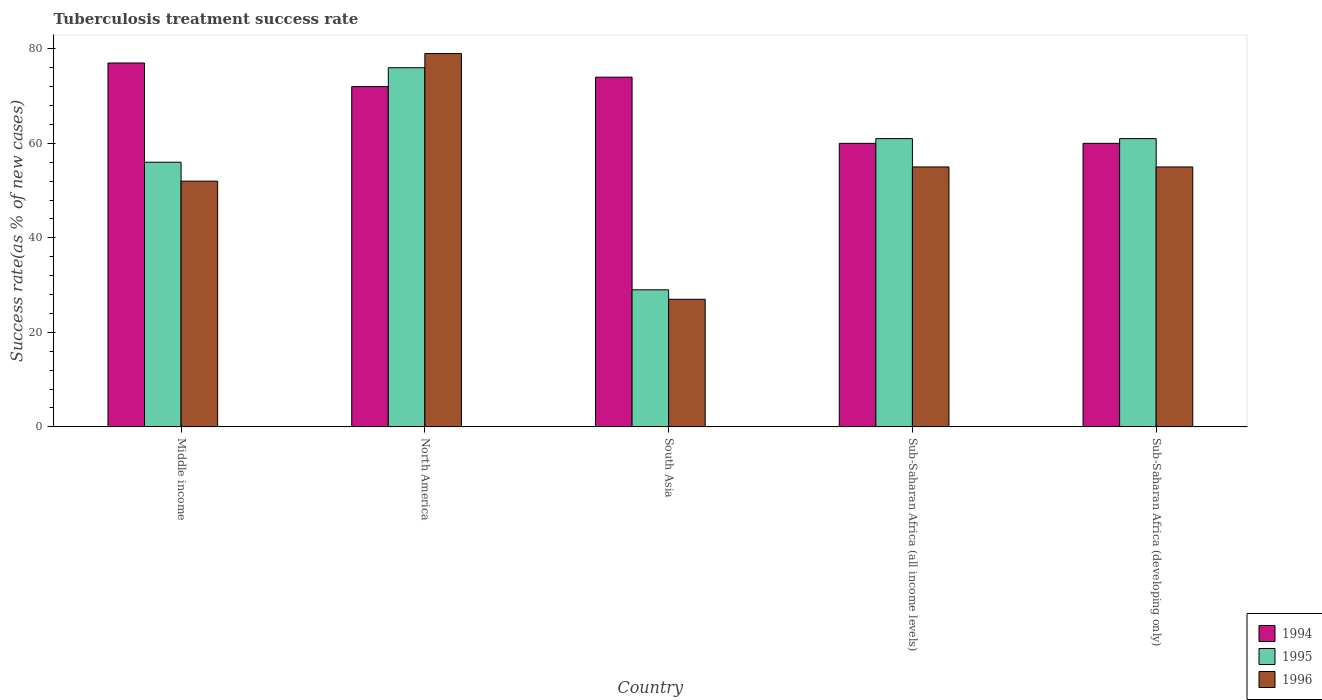How many groups of bars are there?
Make the answer very short. 5. How many bars are there on the 5th tick from the right?
Give a very brief answer. 3. What is the label of the 4th group of bars from the left?
Provide a short and direct response. Sub-Saharan Africa (all income levels). What is the tuberculosis treatment success rate in 1995 in South Asia?
Offer a very short reply. 29. Across all countries, what is the maximum tuberculosis treatment success rate in 1996?
Your answer should be very brief. 79. Across all countries, what is the minimum tuberculosis treatment success rate in 1995?
Make the answer very short. 29. In which country was the tuberculosis treatment success rate in 1994 maximum?
Your answer should be very brief. Middle income. What is the total tuberculosis treatment success rate in 1994 in the graph?
Ensure brevity in your answer.  343. What is the average tuberculosis treatment success rate in 1994 per country?
Make the answer very short. 68.6. What is the difference between the tuberculosis treatment success rate of/in 1996 and tuberculosis treatment success rate of/in 1994 in South Asia?
Give a very brief answer. -47. In how many countries, is the tuberculosis treatment success rate in 1996 greater than 36 %?
Your response must be concise. 4. What is the ratio of the tuberculosis treatment success rate in 1995 in Middle income to that in Sub-Saharan Africa (all income levels)?
Your answer should be compact. 0.92. Is the difference between the tuberculosis treatment success rate in 1996 in Sub-Saharan Africa (all income levels) and Sub-Saharan Africa (developing only) greater than the difference between the tuberculosis treatment success rate in 1994 in Sub-Saharan Africa (all income levels) and Sub-Saharan Africa (developing only)?
Your answer should be very brief. No. What is the difference between the highest and the lowest tuberculosis treatment success rate in 1996?
Give a very brief answer. 52. Is the sum of the tuberculosis treatment success rate in 1994 in Middle income and Sub-Saharan Africa (developing only) greater than the maximum tuberculosis treatment success rate in 1995 across all countries?
Your answer should be compact. Yes. Is it the case that in every country, the sum of the tuberculosis treatment success rate in 1994 and tuberculosis treatment success rate in 1995 is greater than the tuberculosis treatment success rate in 1996?
Provide a short and direct response. Yes. Are all the bars in the graph horizontal?
Provide a short and direct response. No. What is the difference between two consecutive major ticks on the Y-axis?
Offer a very short reply. 20. Are the values on the major ticks of Y-axis written in scientific E-notation?
Keep it short and to the point. No. What is the title of the graph?
Offer a terse response. Tuberculosis treatment success rate. Does "2014" appear as one of the legend labels in the graph?
Give a very brief answer. No. What is the label or title of the X-axis?
Provide a short and direct response. Country. What is the label or title of the Y-axis?
Make the answer very short. Success rate(as % of new cases). What is the Success rate(as % of new cases) of 1994 in Middle income?
Offer a terse response. 77. What is the Success rate(as % of new cases) in 1995 in Middle income?
Offer a very short reply. 56. What is the Success rate(as % of new cases) of 1996 in Middle income?
Your answer should be very brief. 52. What is the Success rate(as % of new cases) in 1994 in North America?
Your answer should be compact. 72. What is the Success rate(as % of new cases) in 1995 in North America?
Make the answer very short. 76. What is the Success rate(as % of new cases) of 1996 in North America?
Your answer should be compact. 79. What is the Success rate(as % of new cases) in 1994 in South Asia?
Keep it short and to the point. 74. What is the Success rate(as % of new cases) of 1994 in Sub-Saharan Africa (all income levels)?
Offer a terse response. 60. What is the Success rate(as % of new cases) in 1995 in Sub-Saharan Africa (all income levels)?
Your response must be concise. 61. What is the Success rate(as % of new cases) of 1995 in Sub-Saharan Africa (developing only)?
Your answer should be very brief. 61. What is the Success rate(as % of new cases) of 1996 in Sub-Saharan Africa (developing only)?
Your response must be concise. 55. Across all countries, what is the maximum Success rate(as % of new cases) of 1996?
Provide a succinct answer. 79. Across all countries, what is the minimum Success rate(as % of new cases) in 1994?
Your answer should be compact. 60. Across all countries, what is the minimum Success rate(as % of new cases) in 1995?
Give a very brief answer. 29. What is the total Success rate(as % of new cases) in 1994 in the graph?
Offer a terse response. 343. What is the total Success rate(as % of new cases) of 1995 in the graph?
Your answer should be compact. 283. What is the total Success rate(as % of new cases) in 1996 in the graph?
Provide a short and direct response. 268. What is the difference between the Success rate(as % of new cases) in 1994 in Middle income and that in North America?
Make the answer very short. 5. What is the difference between the Success rate(as % of new cases) in 1995 in Middle income and that in North America?
Provide a short and direct response. -20. What is the difference between the Success rate(as % of new cases) in 1996 in Middle income and that in North America?
Keep it short and to the point. -27. What is the difference between the Success rate(as % of new cases) of 1994 in Middle income and that in Sub-Saharan Africa (all income levels)?
Keep it short and to the point. 17. What is the difference between the Success rate(as % of new cases) in 1994 in Middle income and that in Sub-Saharan Africa (developing only)?
Make the answer very short. 17. What is the difference between the Success rate(as % of new cases) in 1996 in Middle income and that in Sub-Saharan Africa (developing only)?
Ensure brevity in your answer.  -3. What is the difference between the Success rate(as % of new cases) of 1994 in North America and that in South Asia?
Ensure brevity in your answer.  -2. What is the difference between the Success rate(as % of new cases) in 1996 in North America and that in South Asia?
Ensure brevity in your answer.  52. What is the difference between the Success rate(as % of new cases) of 1994 in North America and that in Sub-Saharan Africa (all income levels)?
Provide a succinct answer. 12. What is the difference between the Success rate(as % of new cases) of 1995 in North America and that in Sub-Saharan Africa (all income levels)?
Your answer should be very brief. 15. What is the difference between the Success rate(as % of new cases) in 1994 in North America and that in Sub-Saharan Africa (developing only)?
Your answer should be compact. 12. What is the difference between the Success rate(as % of new cases) of 1995 in North America and that in Sub-Saharan Africa (developing only)?
Provide a short and direct response. 15. What is the difference between the Success rate(as % of new cases) of 1995 in South Asia and that in Sub-Saharan Africa (all income levels)?
Make the answer very short. -32. What is the difference between the Success rate(as % of new cases) in 1996 in South Asia and that in Sub-Saharan Africa (all income levels)?
Make the answer very short. -28. What is the difference between the Success rate(as % of new cases) in 1995 in South Asia and that in Sub-Saharan Africa (developing only)?
Your answer should be compact. -32. What is the difference between the Success rate(as % of new cases) in 1996 in South Asia and that in Sub-Saharan Africa (developing only)?
Ensure brevity in your answer.  -28. What is the difference between the Success rate(as % of new cases) in 1996 in Sub-Saharan Africa (all income levels) and that in Sub-Saharan Africa (developing only)?
Keep it short and to the point. 0. What is the difference between the Success rate(as % of new cases) of 1994 in Middle income and the Success rate(as % of new cases) of 1995 in North America?
Keep it short and to the point. 1. What is the difference between the Success rate(as % of new cases) in 1994 in Middle income and the Success rate(as % of new cases) in 1996 in North America?
Keep it short and to the point. -2. What is the difference between the Success rate(as % of new cases) in 1995 in Middle income and the Success rate(as % of new cases) in 1996 in North America?
Your response must be concise. -23. What is the difference between the Success rate(as % of new cases) of 1994 in Middle income and the Success rate(as % of new cases) of 1996 in South Asia?
Keep it short and to the point. 50. What is the difference between the Success rate(as % of new cases) of 1995 in Middle income and the Success rate(as % of new cases) of 1996 in South Asia?
Your response must be concise. 29. What is the difference between the Success rate(as % of new cases) in 1994 in Middle income and the Success rate(as % of new cases) in 1995 in Sub-Saharan Africa (developing only)?
Provide a succinct answer. 16. What is the difference between the Success rate(as % of new cases) in 1994 in North America and the Success rate(as % of new cases) in 1995 in South Asia?
Your response must be concise. 43. What is the difference between the Success rate(as % of new cases) in 1994 in North America and the Success rate(as % of new cases) in 1995 in Sub-Saharan Africa (all income levels)?
Provide a short and direct response. 11. What is the difference between the Success rate(as % of new cases) of 1995 in North America and the Success rate(as % of new cases) of 1996 in Sub-Saharan Africa (all income levels)?
Provide a short and direct response. 21. What is the difference between the Success rate(as % of new cases) of 1994 in North America and the Success rate(as % of new cases) of 1995 in Sub-Saharan Africa (developing only)?
Your answer should be very brief. 11. What is the difference between the Success rate(as % of new cases) in 1995 in North America and the Success rate(as % of new cases) in 1996 in Sub-Saharan Africa (developing only)?
Your answer should be compact. 21. What is the difference between the Success rate(as % of new cases) in 1994 in South Asia and the Success rate(as % of new cases) in 1995 in Sub-Saharan Africa (all income levels)?
Offer a terse response. 13. What is the difference between the Success rate(as % of new cases) in 1994 in South Asia and the Success rate(as % of new cases) in 1996 in Sub-Saharan Africa (all income levels)?
Provide a succinct answer. 19. What is the difference between the Success rate(as % of new cases) of 1994 in South Asia and the Success rate(as % of new cases) of 1995 in Sub-Saharan Africa (developing only)?
Offer a very short reply. 13. What is the difference between the Success rate(as % of new cases) of 1995 in South Asia and the Success rate(as % of new cases) of 1996 in Sub-Saharan Africa (developing only)?
Your response must be concise. -26. What is the average Success rate(as % of new cases) of 1994 per country?
Provide a short and direct response. 68.6. What is the average Success rate(as % of new cases) in 1995 per country?
Your answer should be very brief. 56.6. What is the average Success rate(as % of new cases) in 1996 per country?
Make the answer very short. 53.6. What is the difference between the Success rate(as % of new cases) of 1994 and Success rate(as % of new cases) of 1995 in Middle income?
Make the answer very short. 21. What is the difference between the Success rate(as % of new cases) in 1994 and Success rate(as % of new cases) in 1996 in Middle income?
Keep it short and to the point. 25. What is the difference between the Success rate(as % of new cases) in 1994 and Success rate(as % of new cases) in 1995 in North America?
Make the answer very short. -4. What is the difference between the Success rate(as % of new cases) in 1994 and Success rate(as % of new cases) in 1996 in North America?
Your response must be concise. -7. What is the difference between the Success rate(as % of new cases) in 1994 and Success rate(as % of new cases) in 1995 in South Asia?
Give a very brief answer. 45. What is the difference between the Success rate(as % of new cases) in 1994 and Success rate(as % of new cases) in 1996 in South Asia?
Your response must be concise. 47. What is the difference between the Success rate(as % of new cases) in 1995 and Success rate(as % of new cases) in 1996 in South Asia?
Provide a succinct answer. 2. What is the difference between the Success rate(as % of new cases) in 1994 and Success rate(as % of new cases) in 1996 in Sub-Saharan Africa (all income levels)?
Your response must be concise. 5. What is the difference between the Success rate(as % of new cases) of 1995 and Success rate(as % of new cases) of 1996 in Sub-Saharan Africa (all income levels)?
Your answer should be compact. 6. What is the difference between the Success rate(as % of new cases) of 1995 and Success rate(as % of new cases) of 1996 in Sub-Saharan Africa (developing only)?
Offer a terse response. 6. What is the ratio of the Success rate(as % of new cases) of 1994 in Middle income to that in North America?
Your answer should be very brief. 1.07. What is the ratio of the Success rate(as % of new cases) in 1995 in Middle income to that in North America?
Ensure brevity in your answer.  0.74. What is the ratio of the Success rate(as % of new cases) in 1996 in Middle income to that in North America?
Provide a short and direct response. 0.66. What is the ratio of the Success rate(as % of new cases) of 1994 in Middle income to that in South Asia?
Keep it short and to the point. 1.04. What is the ratio of the Success rate(as % of new cases) in 1995 in Middle income to that in South Asia?
Your response must be concise. 1.93. What is the ratio of the Success rate(as % of new cases) in 1996 in Middle income to that in South Asia?
Provide a short and direct response. 1.93. What is the ratio of the Success rate(as % of new cases) of 1994 in Middle income to that in Sub-Saharan Africa (all income levels)?
Give a very brief answer. 1.28. What is the ratio of the Success rate(as % of new cases) in 1995 in Middle income to that in Sub-Saharan Africa (all income levels)?
Provide a succinct answer. 0.92. What is the ratio of the Success rate(as % of new cases) of 1996 in Middle income to that in Sub-Saharan Africa (all income levels)?
Your response must be concise. 0.95. What is the ratio of the Success rate(as % of new cases) in 1994 in Middle income to that in Sub-Saharan Africa (developing only)?
Provide a succinct answer. 1.28. What is the ratio of the Success rate(as % of new cases) in 1995 in Middle income to that in Sub-Saharan Africa (developing only)?
Give a very brief answer. 0.92. What is the ratio of the Success rate(as % of new cases) of 1996 in Middle income to that in Sub-Saharan Africa (developing only)?
Offer a terse response. 0.95. What is the ratio of the Success rate(as % of new cases) of 1994 in North America to that in South Asia?
Your answer should be very brief. 0.97. What is the ratio of the Success rate(as % of new cases) of 1995 in North America to that in South Asia?
Provide a succinct answer. 2.62. What is the ratio of the Success rate(as % of new cases) in 1996 in North America to that in South Asia?
Ensure brevity in your answer.  2.93. What is the ratio of the Success rate(as % of new cases) in 1994 in North America to that in Sub-Saharan Africa (all income levels)?
Your response must be concise. 1.2. What is the ratio of the Success rate(as % of new cases) of 1995 in North America to that in Sub-Saharan Africa (all income levels)?
Provide a succinct answer. 1.25. What is the ratio of the Success rate(as % of new cases) of 1996 in North America to that in Sub-Saharan Africa (all income levels)?
Offer a very short reply. 1.44. What is the ratio of the Success rate(as % of new cases) in 1994 in North America to that in Sub-Saharan Africa (developing only)?
Give a very brief answer. 1.2. What is the ratio of the Success rate(as % of new cases) in 1995 in North America to that in Sub-Saharan Africa (developing only)?
Give a very brief answer. 1.25. What is the ratio of the Success rate(as % of new cases) of 1996 in North America to that in Sub-Saharan Africa (developing only)?
Give a very brief answer. 1.44. What is the ratio of the Success rate(as % of new cases) of 1994 in South Asia to that in Sub-Saharan Africa (all income levels)?
Ensure brevity in your answer.  1.23. What is the ratio of the Success rate(as % of new cases) in 1995 in South Asia to that in Sub-Saharan Africa (all income levels)?
Offer a very short reply. 0.48. What is the ratio of the Success rate(as % of new cases) in 1996 in South Asia to that in Sub-Saharan Africa (all income levels)?
Give a very brief answer. 0.49. What is the ratio of the Success rate(as % of new cases) of 1994 in South Asia to that in Sub-Saharan Africa (developing only)?
Your response must be concise. 1.23. What is the ratio of the Success rate(as % of new cases) in 1995 in South Asia to that in Sub-Saharan Africa (developing only)?
Keep it short and to the point. 0.48. What is the ratio of the Success rate(as % of new cases) in 1996 in South Asia to that in Sub-Saharan Africa (developing only)?
Your answer should be very brief. 0.49. What is the ratio of the Success rate(as % of new cases) in 1995 in Sub-Saharan Africa (all income levels) to that in Sub-Saharan Africa (developing only)?
Keep it short and to the point. 1. What is the difference between the highest and the second highest Success rate(as % of new cases) of 1994?
Give a very brief answer. 3. What is the difference between the highest and the second highest Success rate(as % of new cases) in 1995?
Provide a succinct answer. 15. What is the difference between the highest and the lowest Success rate(as % of new cases) in 1995?
Ensure brevity in your answer.  47. 